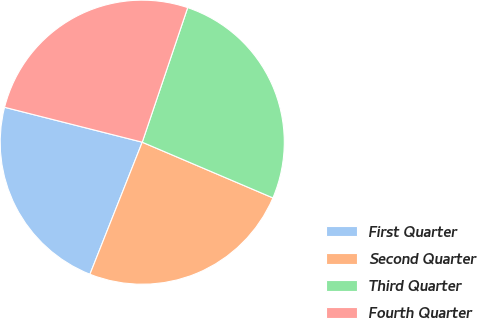Convert chart. <chart><loc_0><loc_0><loc_500><loc_500><pie_chart><fcel>First Quarter<fcel>Second Quarter<fcel>Third Quarter<fcel>Fourth Quarter<nl><fcel>22.95%<fcel>24.59%<fcel>26.23%<fcel>26.23%<nl></chart> 